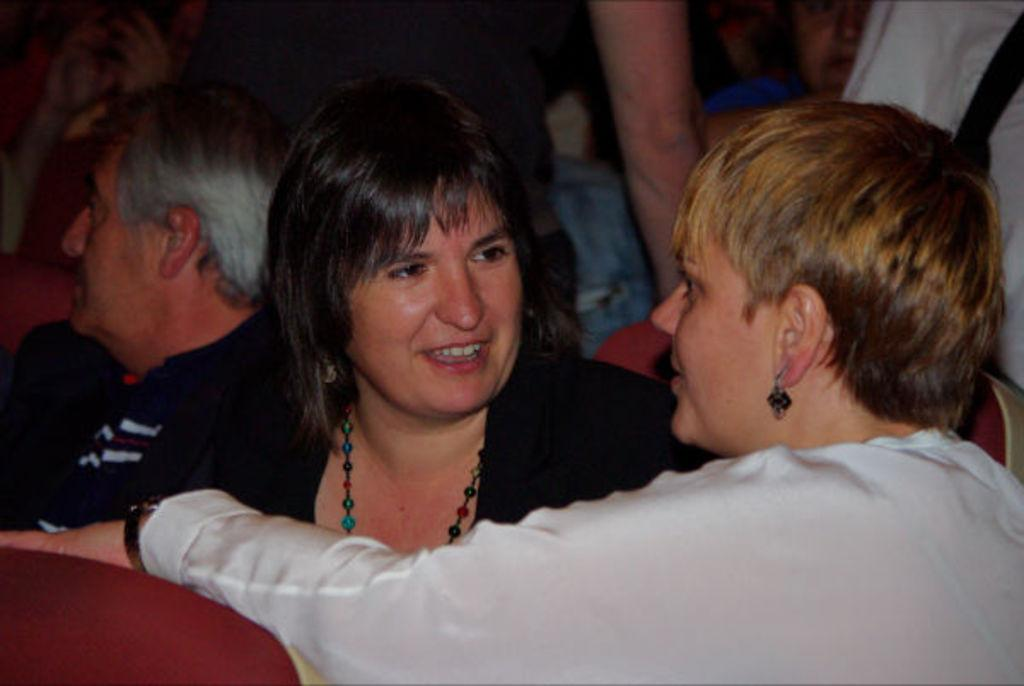How many women are in the image? There are two women in the image. What are the women doing in the image? The women are sitting in the front and smiling. What activity are the women engaged in? The women are talking to each other. Are there any other people visible in the image? Yes, there are people standing behind the women. What type of clouds can be seen in the picture? There is no picture or clouds present in the image; it features two women sitting and talking. 